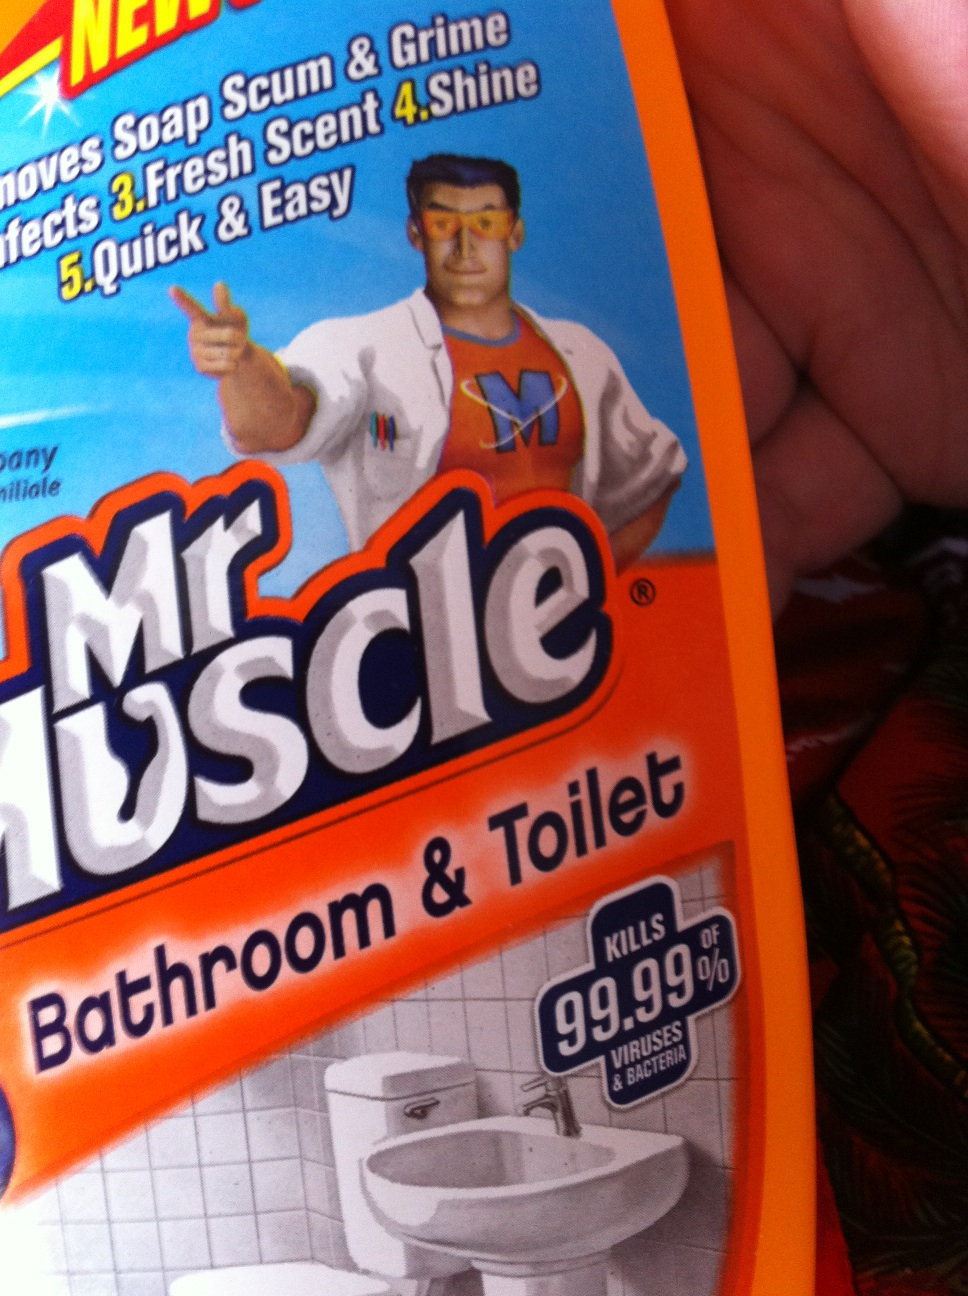Can this cleaner also be used for general household cleaning, or is it specifically for bathrooms? This cleaner is especially formulated for bathroom cleaning, targeting common bathroom dirt and grime like soap scum. While it might be effective in some other areas, it's best to use products designed for the specific cleaning task at hand to ensure the best result and surface safety. 